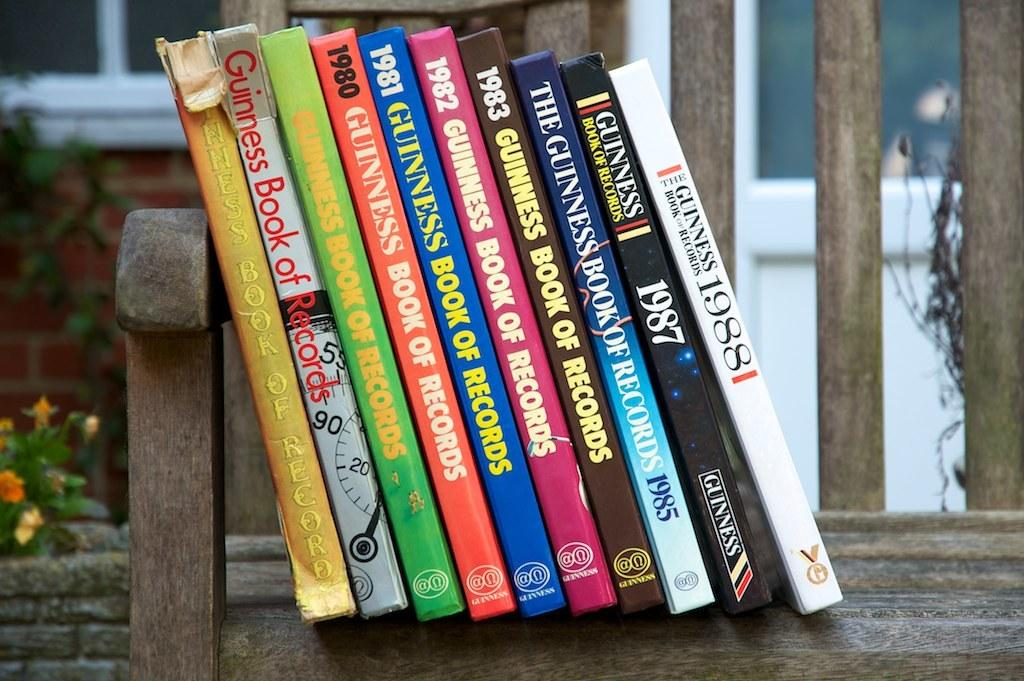<image>
Present a compact description of the photo's key features. A stack of Guinness Book of Records books on a wood shelf 